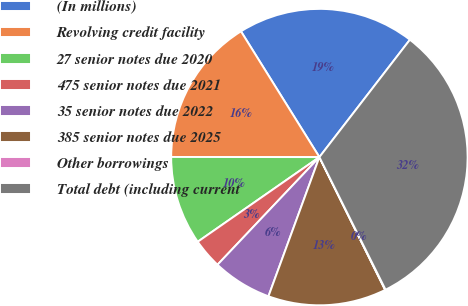Convert chart to OTSL. <chart><loc_0><loc_0><loc_500><loc_500><pie_chart><fcel>(In millions)<fcel>Revolving credit facility<fcel>27 senior notes due 2020<fcel>475 senior notes due 2021<fcel>35 senior notes due 2022<fcel>385 senior notes due 2025<fcel>Other borrowings<fcel>Total debt (including current<nl><fcel>19.33%<fcel>16.11%<fcel>9.69%<fcel>3.26%<fcel>6.48%<fcel>12.9%<fcel>0.05%<fcel>32.18%<nl></chart> 